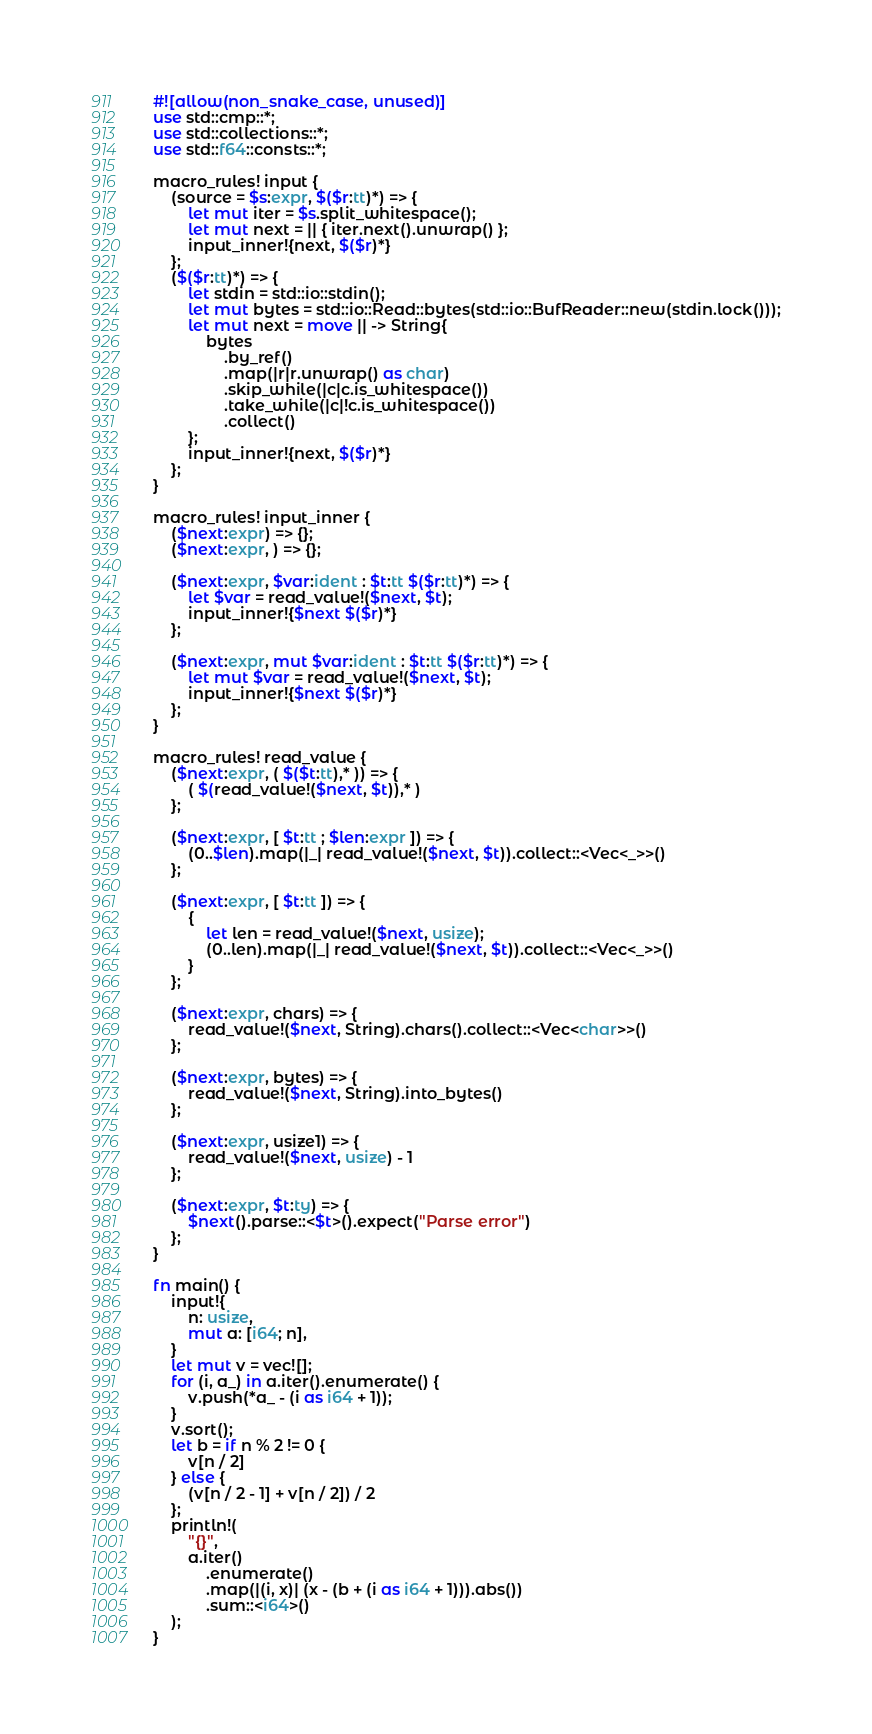<code> <loc_0><loc_0><loc_500><loc_500><_Rust_>#![allow(non_snake_case, unused)]
use std::cmp::*;
use std::collections::*;
use std::f64::consts::*;

macro_rules! input {
    (source = $s:expr, $($r:tt)*) => {
        let mut iter = $s.split_whitespace();
        let mut next = || { iter.next().unwrap() };
        input_inner!{next, $($r)*}
    };
    ($($r:tt)*) => {
        let stdin = std::io::stdin();
        let mut bytes = std::io::Read::bytes(std::io::BufReader::new(stdin.lock()));
        let mut next = move || -> String{
            bytes
                .by_ref()
                .map(|r|r.unwrap() as char)
                .skip_while(|c|c.is_whitespace())
                .take_while(|c|!c.is_whitespace())
                .collect()
        };
        input_inner!{next, $($r)*}
    };
}

macro_rules! input_inner {
    ($next:expr) => {};
    ($next:expr, ) => {};

    ($next:expr, $var:ident : $t:tt $($r:tt)*) => {
        let $var = read_value!($next, $t);
        input_inner!{$next $($r)*}
    };

    ($next:expr, mut $var:ident : $t:tt $($r:tt)*) => {
        let mut $var = read_value!($next, $t);
        input_inner!{$next $($r)*}
    };
}

macro_rules! read_value {
    ($next:expr, ( $($t:tt),* )) => {
        ( $(read_value!($next, $t)),* )
    };

    ($next:expr, [ $t:tt ; $len:expr ]) => {
        (0..$len).map(|_| read_value!($next, $t)).collect::<Vec<_>>()
    };

    ($next:expr, [ $t:tt ]) => {
        {
            let len = read_value!($next, usize);
            (0..len).map(|_| read_value!($next, $t)).collect::<Vec<_>>()
        }
    };

    ($next:expr, chars) => {
        read_value!($next, String).chars().collect::<Vec<char>>()
    };

    ($next:expr, bytes) => {
        read_value!($next, String).into_bytes()
    };

    ($next:expr, usize1) => {
        read_value!($next, usize) - 1
    };

    ($next:expr, $t:ty) => {
        $next().parse::<$t>().expect("Parse error")
    };
}

fn main() {
    input!{
        n: usize,
        mut a: [i64; n],
    }
    let mut v = vec![];
    for (i, a_) in a.iter().enumerate() {
        v.push(*a_ - (i as i64 + 1));
    }
    v.sort();
    let b = if n % 2 != 0 {
        v[n / 2]
    } else {
        (v[n / 2 - 1] + v[n / 2]) / 2
    };
    println!(
        "{}",
        a.iter()
            .enumerate()
            .map(|(i, x)| (x - (b + (i as i64 + 1))).abs())
            .sum::<i64>()
    );
}
</code> 